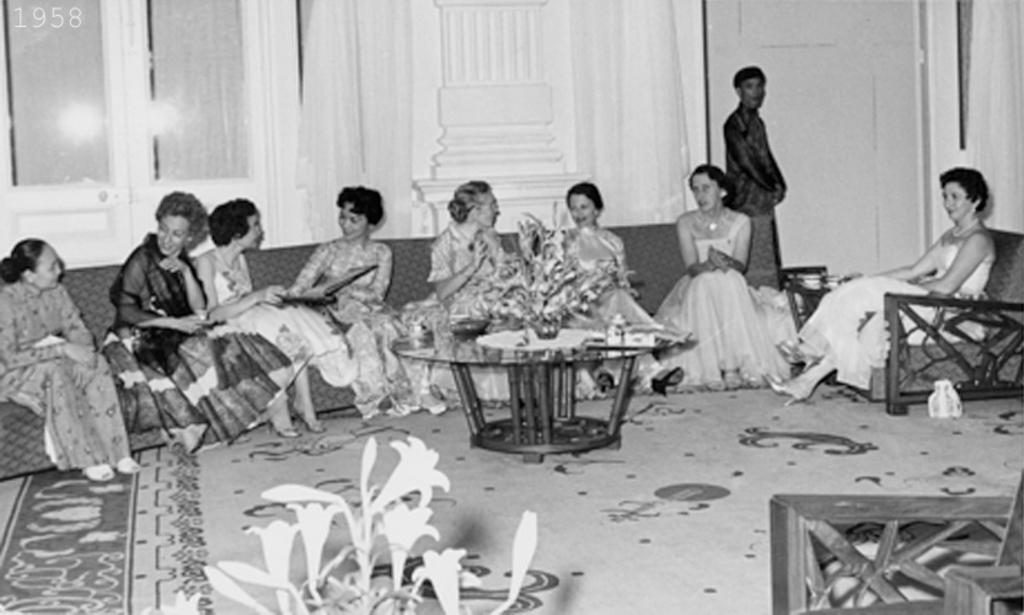Describe this image in one or two sentences. In this image I can see there are few women sitting on sofa chairs and in front of them I can see a table on the table I can see flower pots, at the bottom I can see flowers and at the top I can see the wall , in front of the wall I can see a person. 